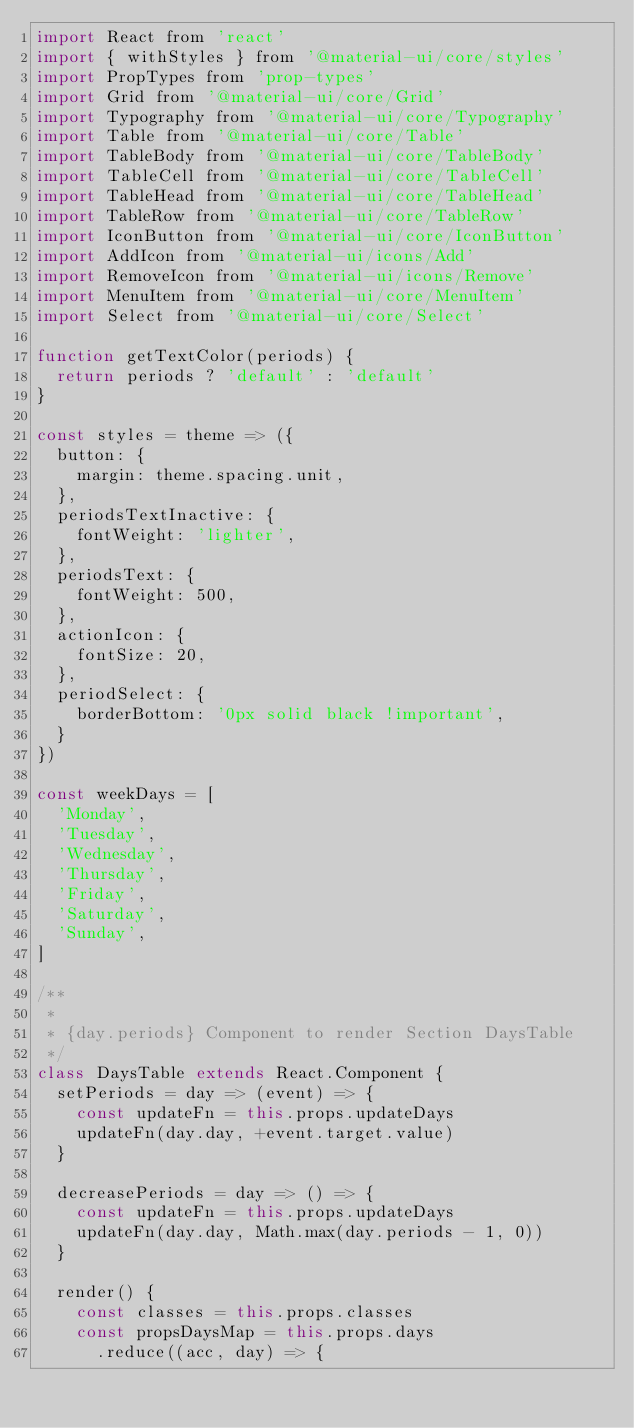<code> <loc_0><loc_0><loc_500><loc_500><_JavaScript_>import React from 'react'
import { withStyles } from '@material-ui/core/styles'
import PropTypes from 'prop-types'
import Grid from '@material-ui/core/Grid'
import Typography from '@material-ui/core/Typography'
import Table from '@material-ui/core/Table'
import TableBody from '@material-ui/core/TableBody'
import TableCell from '@material-ui/core/TableCell'
import TableHead from '@material-ui/core/TableHead'
import TableRow from '@material-ui/core/TableRow'
import IconButton from '@material-ui/core/IconButton'
import AddIcon from '@material-ui/icons/Add'
import RemoveIcon from '@material-ui/icons/Remove'
import MenuItem from '@material-ui/core/MenuItem'
import Select from '@material-ui/core/Select'

function getTextColor(periods) {
  return periods ? 'default' : 'default'
}

const styles = theme => ({
  button: {
    margin: theme.spacing.unit,
  },
  periodsTextInactive: {
    fontWeight: 'lighter',
  },
  periodsText: {
    fontWeight: 500,
  },
  actionIcon: {
    fontSize: 20,
  },
  periodSelect: {
    borderBottom: '0px solid black !important',
  }
})

const weekDays = [
  'Monday',
  'Tuesday',
  'Wednesday',
  'Thursday',
  'Friday',
  'Saturday',
  'Sunday',
]

/**
 *
 * {day.periods} Component to render Section DaysTable
 */
class DaysTable extends React.Component {
  setPeriods = day => (event) => {
    const updateFn = this.props.updateDays
    updateFn(day.day, +event.target.value)
  }

  decreasePeriods = day => () => {
    const updateFn = this.props.updateDays
    updateFn(day.day, Math.max(day.periods - 1, 0))
  }

  render() {
    const classes = this.props.classes
    const propsDaysMap = this.props.days
      .reduce((acc, day) => {</code> 